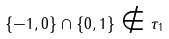<formula> <loc_0><loc_0><loc_500><loc_500>\{ - 1 , 0 \} \cap \{ 0 , 1 \} \notin \tau _ { 1 }</formula> 